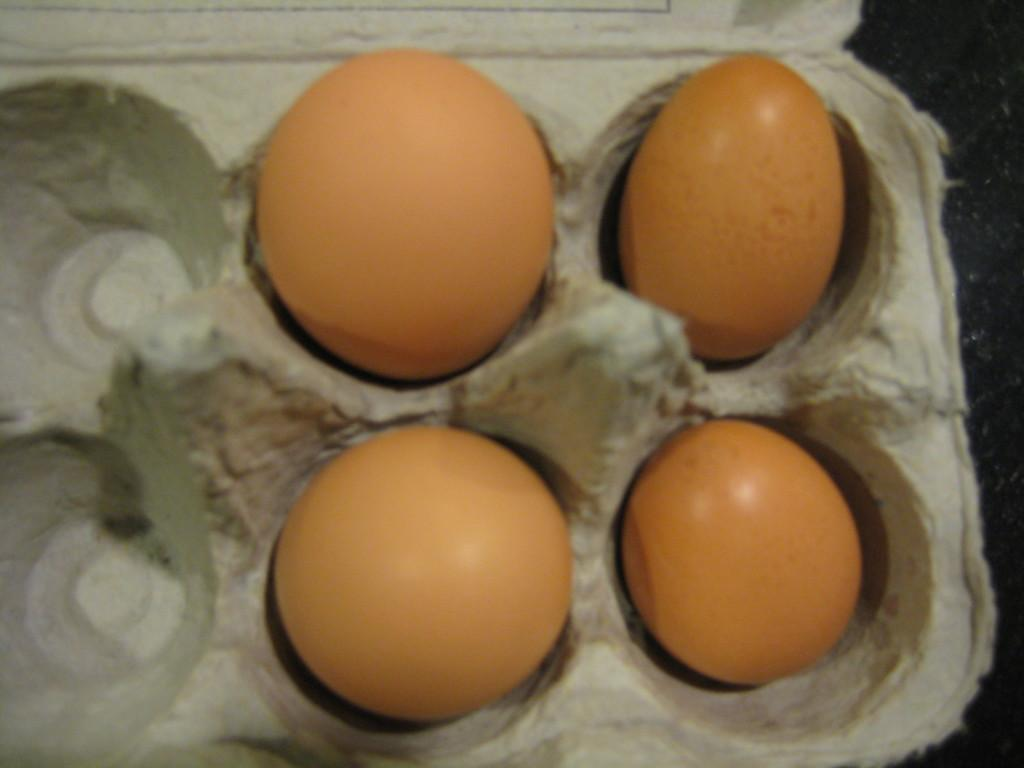How many eggs are visible in the image? There are four eggs in the image. How are the eggs arranged or organized in the image? The eggs are kept in an egg tray. How many children are playing with the dogs in the image? There are no children or dogs present in the image; it only features four eggs in an egg tray. 